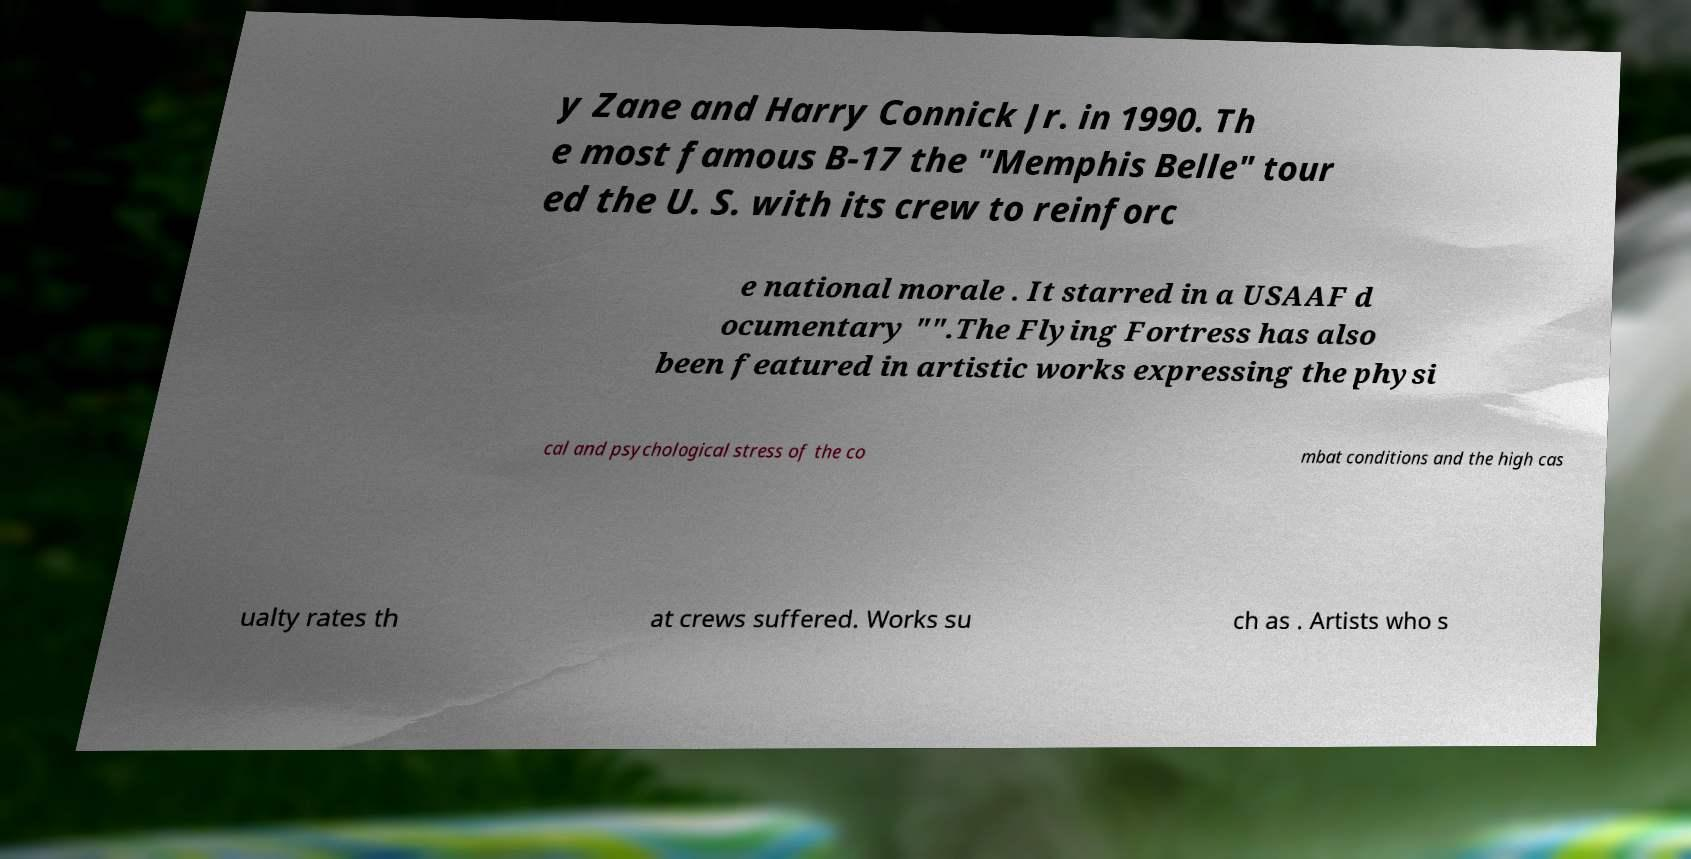Can you read and provide the text displayed in the image?This photo seems to have some interesting text. Can you extract and type it out for me? y Zane and Harry Connick Jr. in 1990. Th e most famous B-17 the "Memphis Belle" tour ed the U. S. with its crew to reinforc e national morale . It starred in a USAAF d ocumentary "".The Flying Fortress has also been featured in artistic works expressing the physi cal and psychological stress of the co mbat conditions and the high cas ualty rates th at crews suffered. Works su ch as . Artists who s 